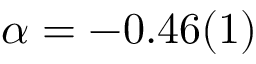Convert formula to latex. <formula><loc_0><loc_0><loc_500><loc_500>\alpha = - 0 . 4 6 ( 1 )</formula> 